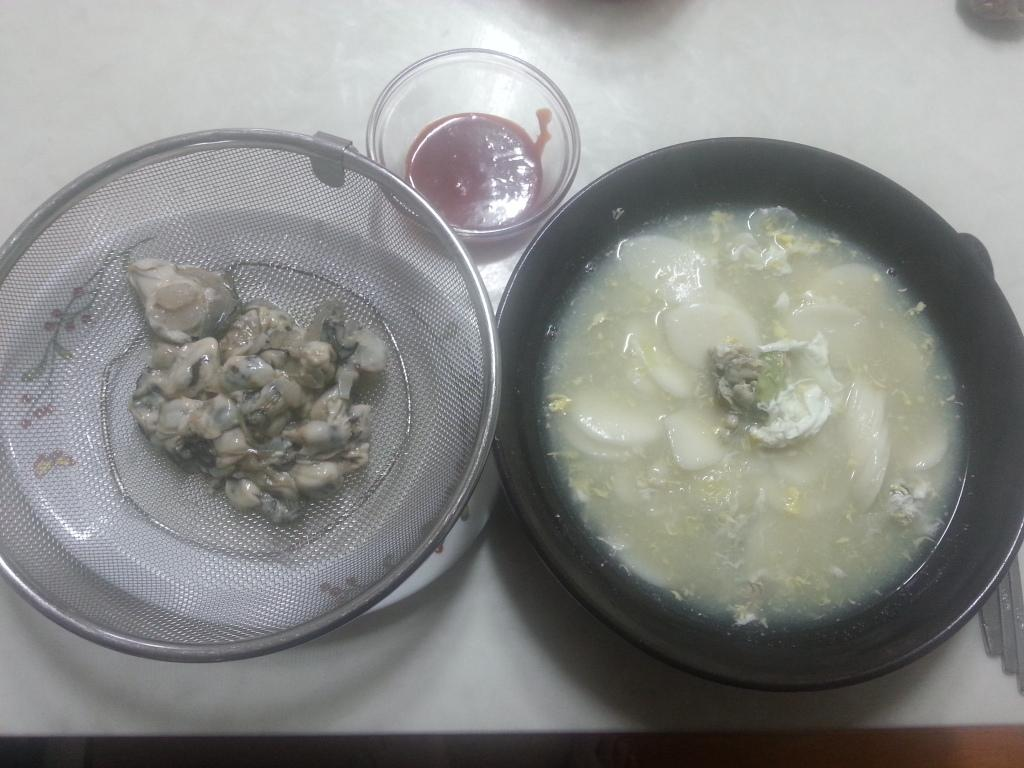What is in the bowls that are visible in the image? There is food in the bowls in the image. What utensils are present beside the bowls in the image? There are spoons beside the bowls in the image. What type of wood can be seen in the image? There is no wood present in the image. Is there any crime being committed in the image? There is no indication of any crime being committed in the image. 